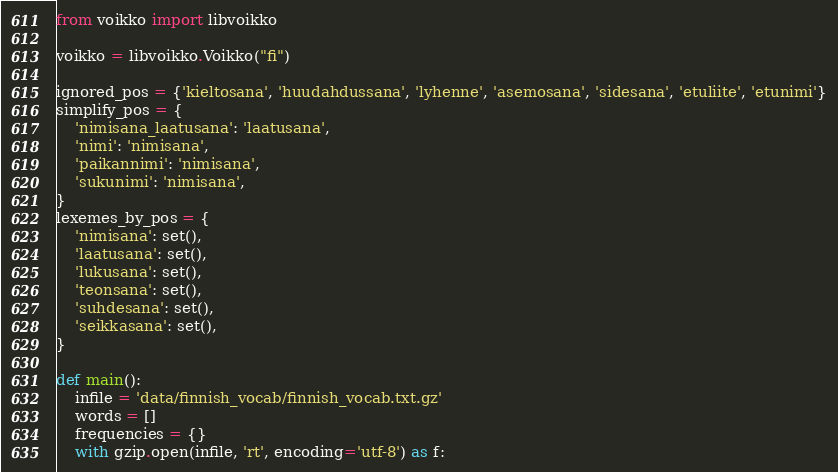<code> <loc_0><loc_0><loc_500><loc_500><_Python_>from voikko import libvoikko

voikko = libvoikko.Voikko("fi")

ignored_pos = {'kieltosana', 'huudahdussana', 'lyhenne', 'asemosana', 'sidesana', 'etuliite', 'etunimi'}
simplify_pos = {
    'nimisana_laatusana': 'laatusana',
    'nimi': 'nimisana',
    'paikannimi': 'nimisana',
    'sukunimi': 'nimisana',
}
lexemes_by_pos = {
    'nimisana': set(),
    'laatusana': set(),
    'lukusana': set(),
    'teonsana': set(),
    'suhdesana': set(),
    'seikkasana': set(),
}

def main():
    infile = 'data/finnish_vocab/finnish_vocab.txt.gz'
    words = []
    frequencies = {}
    with gzip.open(infile, 'rt', encoding='utf-8') as f:</code> 